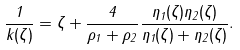Convert formula to latex. <formula><loc_0><loc_0><loc_500><loc_500>\frac { 1 } { k ( \zeta ) } = \zeta + \frac { 4 } { \rho _ { 1 } + \rho _ { 2 } } \frac { \eta _ { 1 } ( \zeta ) \eta _ { 2 } ( \zeta ) } { \eta _ { 1 } ( \zeta ) + \eta _ { 2 } ( \zeta ) } .</formula> 